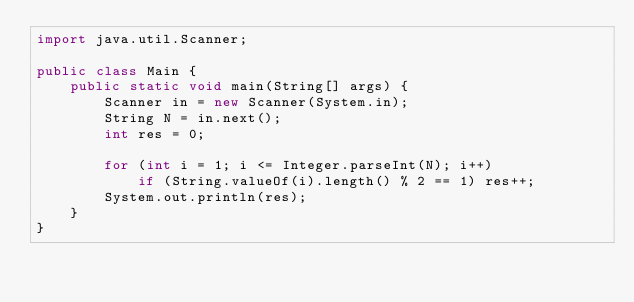Convert code to text. <code><loc_0><loc_0><loc_500><loc_500><_Java_>import java.util.Scanner;

public class Main {
    public static void main(String[] args) {
        Scanner in = new Scanner(System.in);
        String N = in.next();
        int res = 0;

        for (int i = 1; i <= Integer.parseInt(N); i++)
            if (String.valueOf(i).length() % 2 == 1) res++;
        System.out.println(res);
    }
}
</code> 